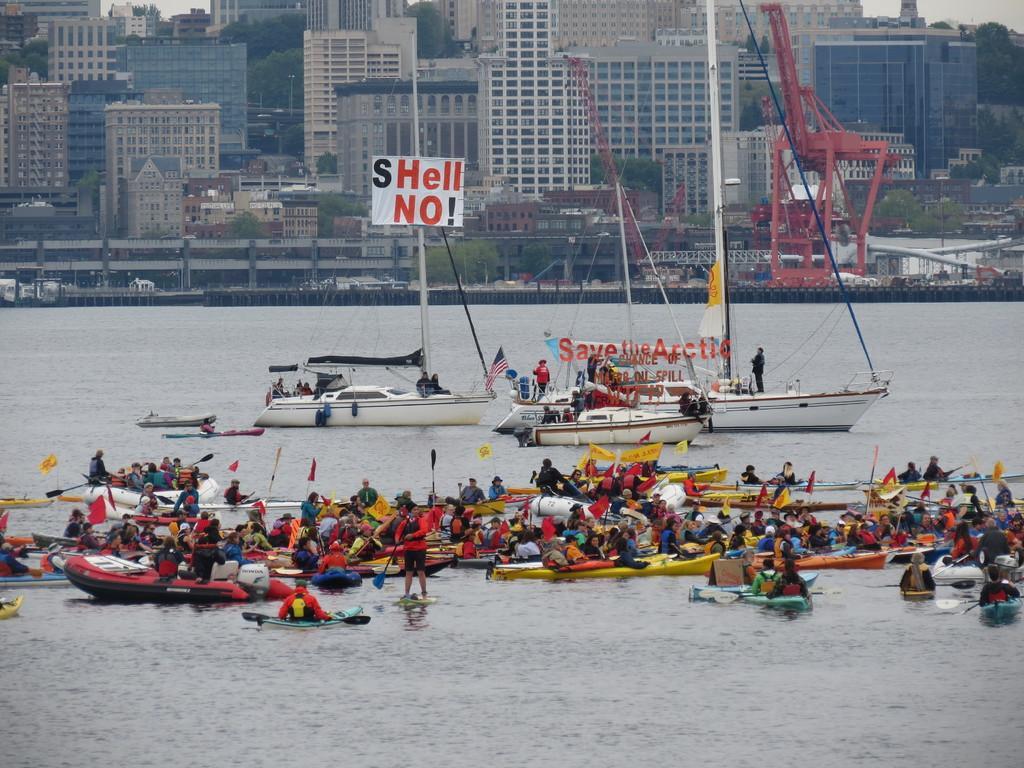Could you give a brief overview of what you see in this image? In this picture we can see a group of boats on water and a group of people sitting on it and in the background we can see buildings, trees, vehicles and trees. 